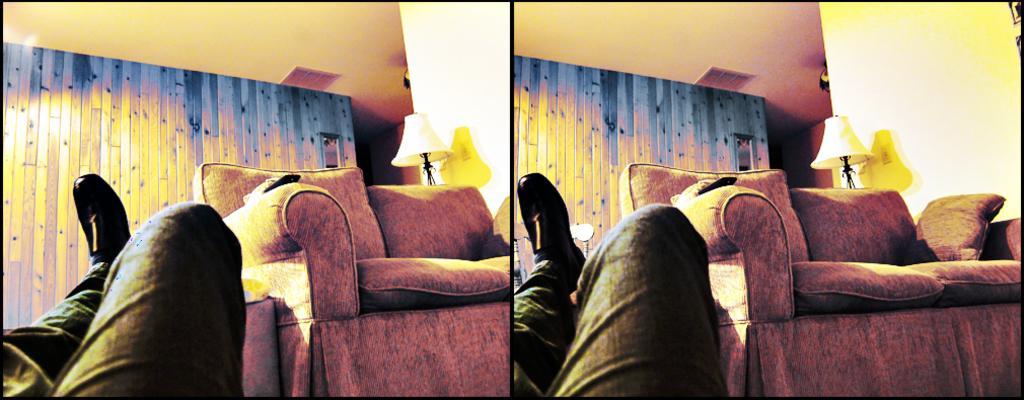Please provide a concise description of this image. The picture is divided into two equal halves where both are same , a guy is sleeping and a brown sofa is next to him and in the background we observe lamps and there is a blue color wall in the background. 